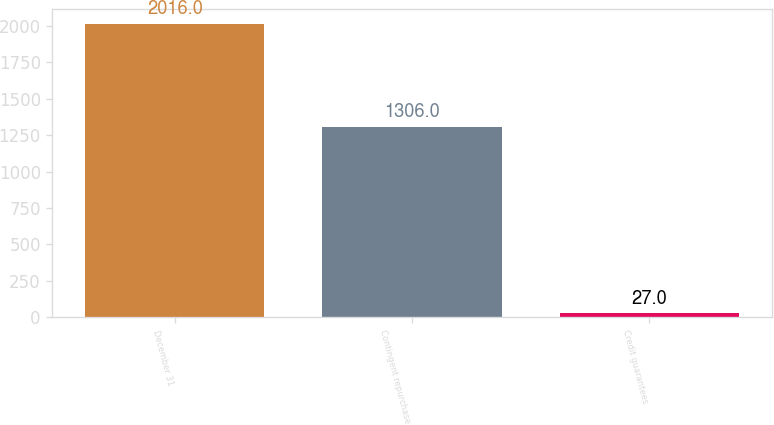Convert chart. <chart><loc_0><loc_0><loc_500><loc_500><bar_chart><fcel>December 31<fcel>Contingent repurchase<fcel>Credit guarantees<nl><fcel>2016<fcel>1306<fcel>27<nl></chart> 